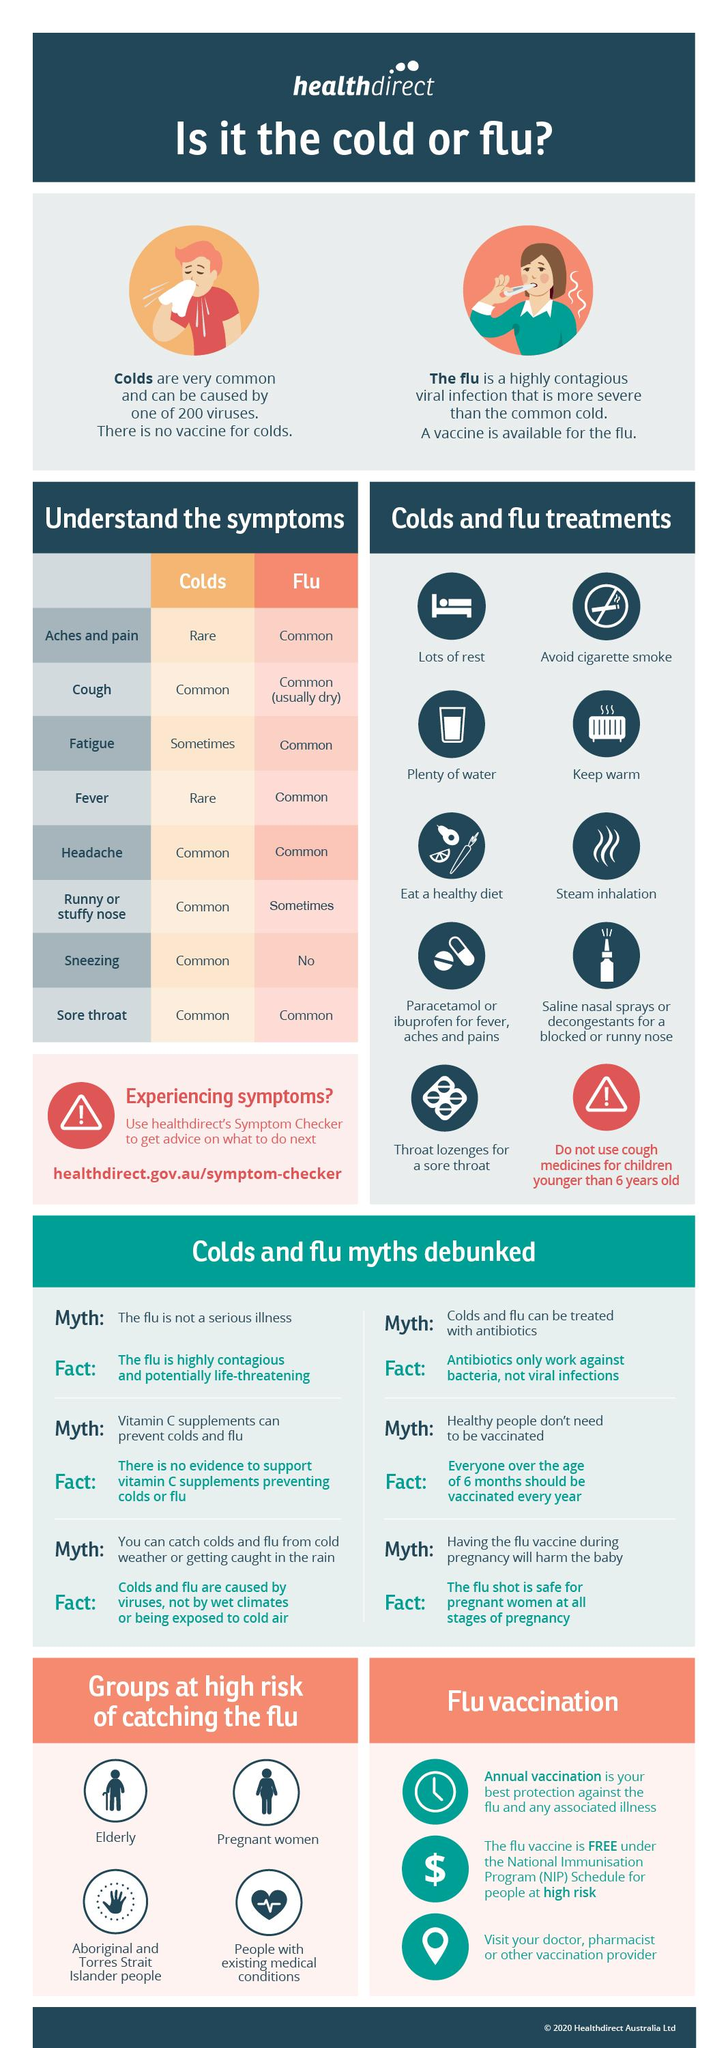Highlight a few significant elements in this photo. Five symptoms are commonly associated with the common cold. The common symptoms of the flu are six in number. Four groups are at high risk of catching the flu. There are only two rare symptoms associated with the common cold. It is uncommon for cold symptoms to include aches and pain, as well as fever. 